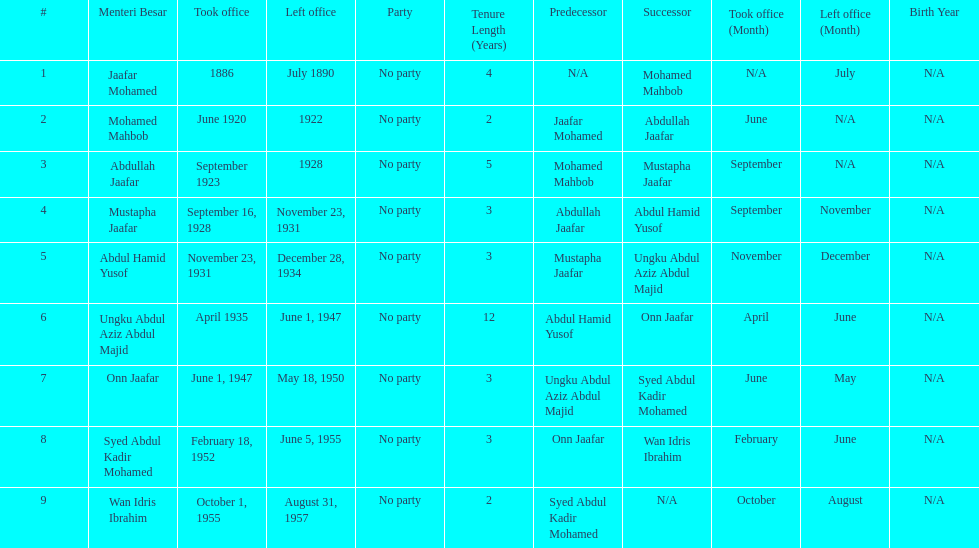What was the date the last person on the list left office? August 31, 1957. 